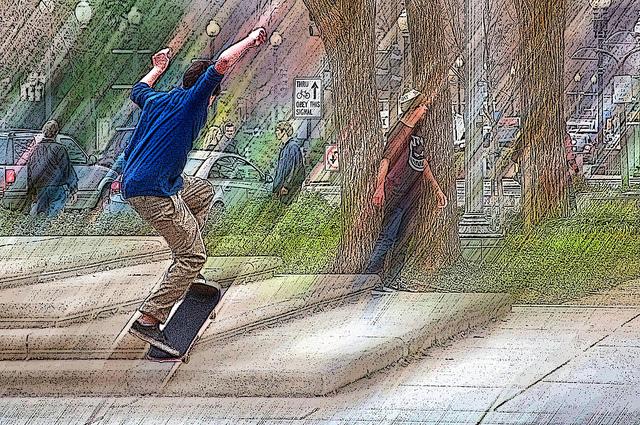What is the guy skating on?
Quick response, please. Skateboard. Is this a piece of art?
Write a very short answer. Yes. Are there cars in this picture?
Keep it brief. Yes. 